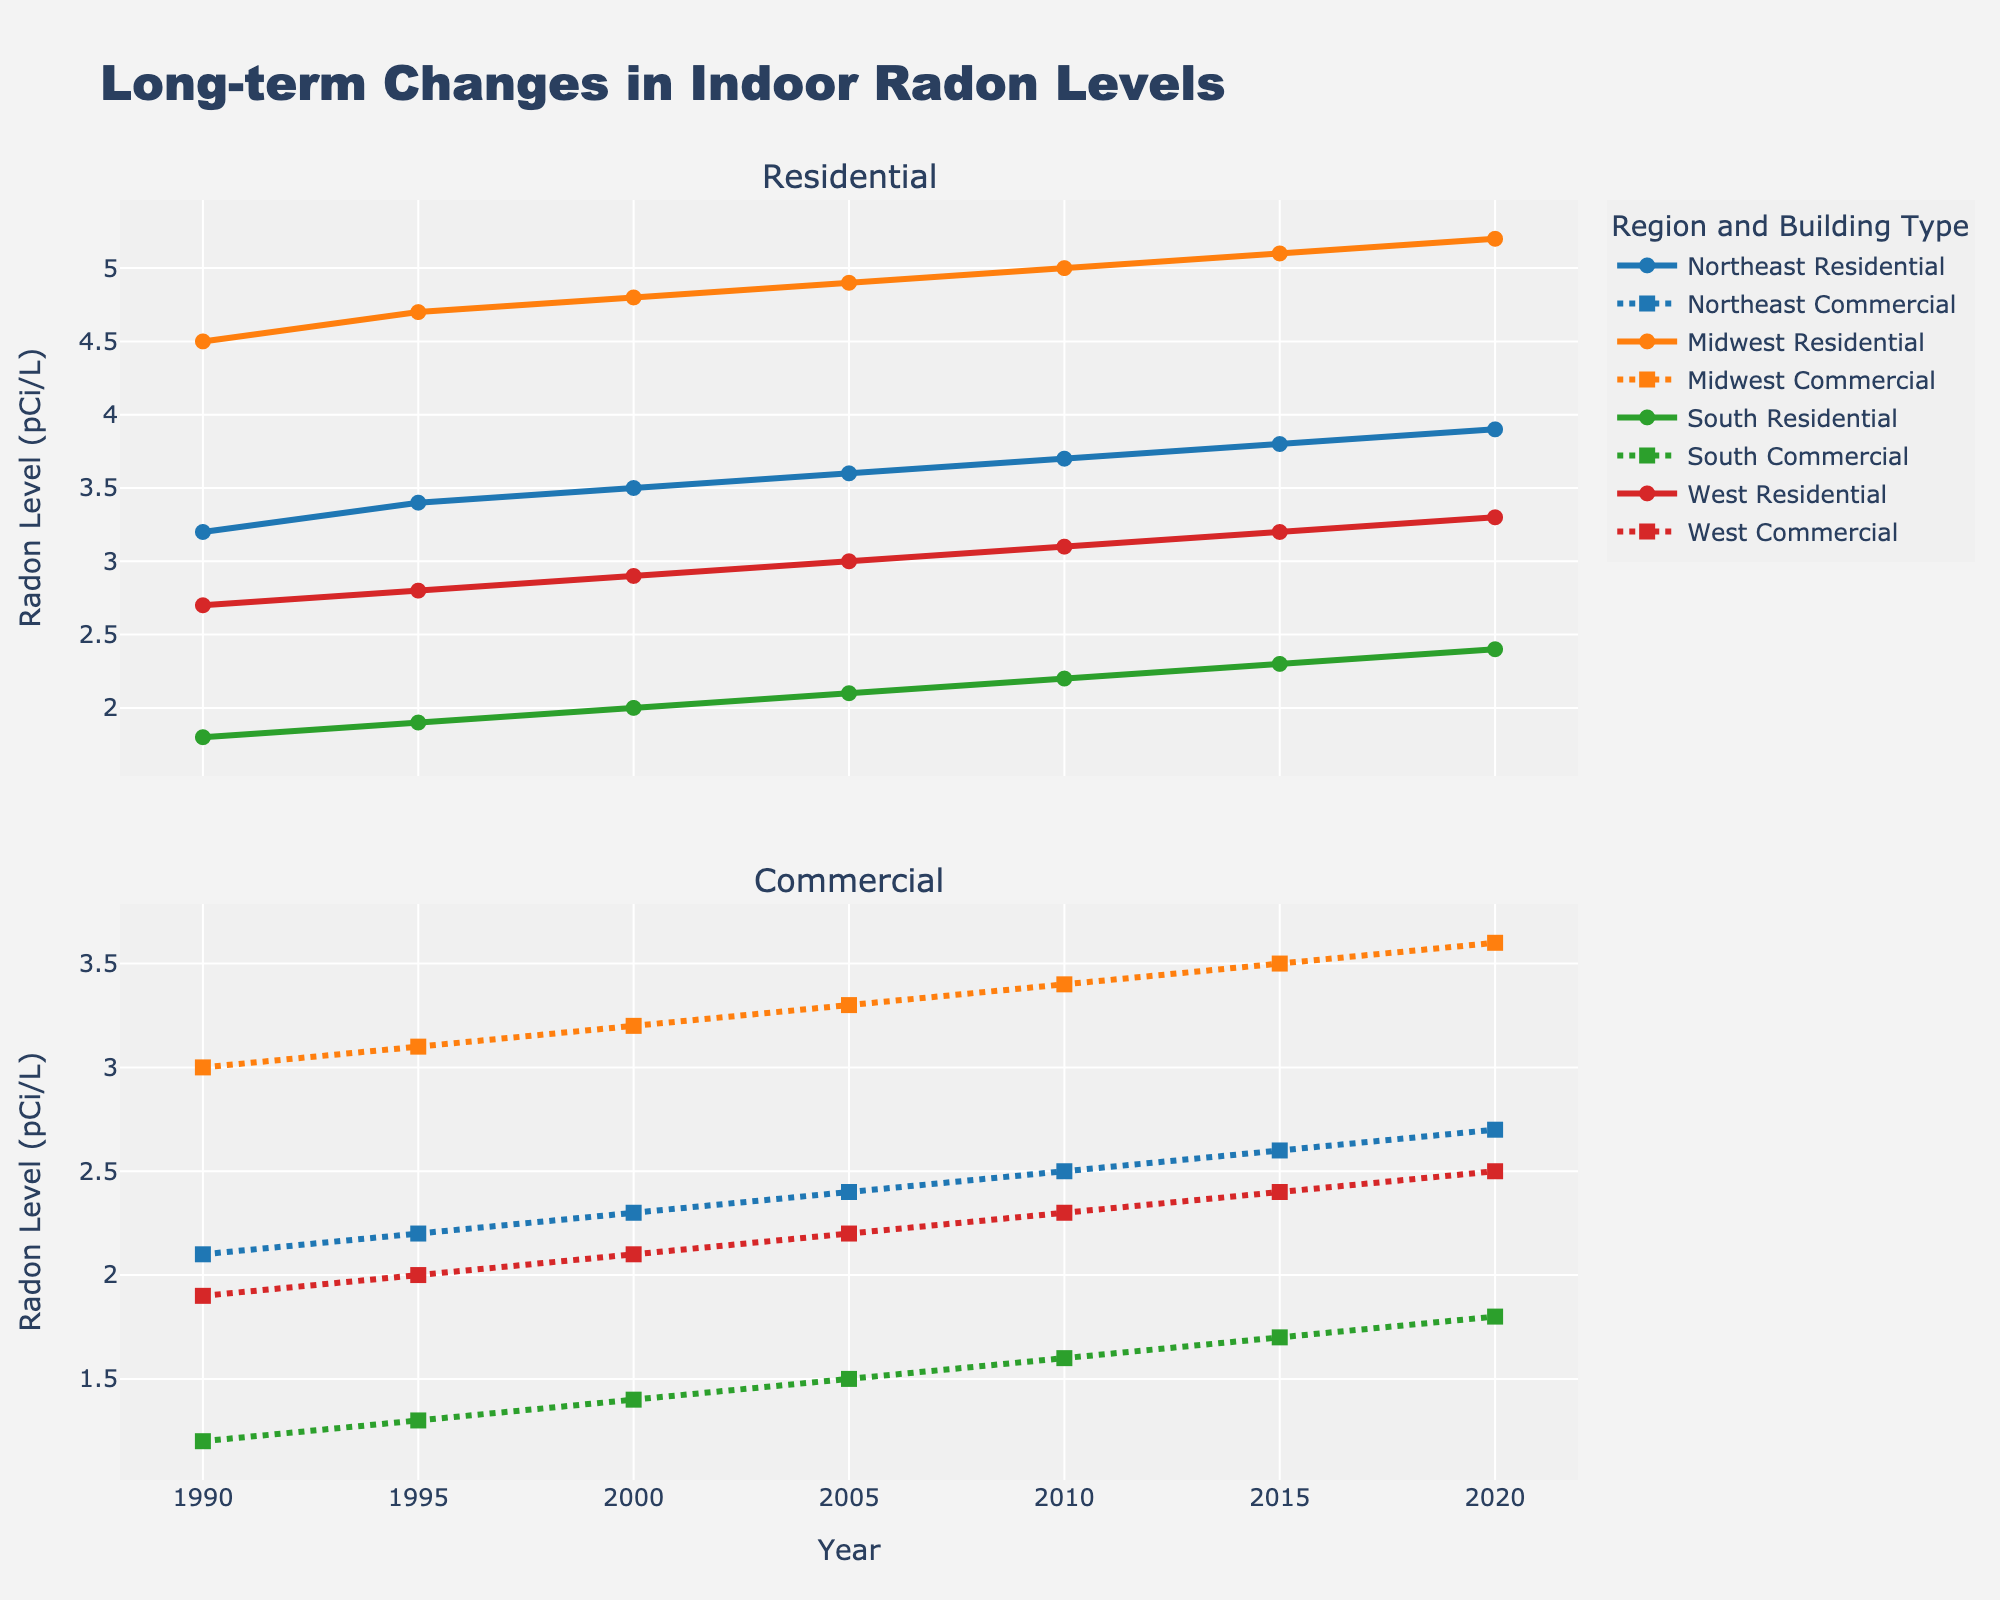Which region shows the highest residential radon level in 2020? Look at the line chart under the year 2020 in the upper subplot and check for the highest point. The Midwest Residential line reaches the highest value.
Answer: Midwest How did the radon levels in South Commercial buildings change from 1990 to 2020? Follow the South Commercial line in the lower subplot from 1990 to 2020. The values increased from 1.2 in 1990 to 1.8 in 2020.
Answer: Increased What is the general trend of radon levels in Northeast Residential buildings from 1990 to 2020? Observe the Northeast Residential line in the upper subplot. The line shows a steady upward trend from 1990 to 2020.
Answer: Upward trend Compare the radon levels in Midwest Commercial buildings to South Residential buildings in 2010. Which one is higher? Locate the year 2010 on the horizontal axis and compare the values of Midwest Commercial and South Residential lines. Midwest Commercial (3.4) is higher than South Residential (2.2).
Answer: Midwest Commercial What is the average radon level in West Residential buildings from 1990 to 2020? Sum the values for West Residential from each year and divide by the number of years ((2.7+2.8+2.9+3.0+3.1+3.2+3.3)/7).
Answer: 2.86 How much did the radon level in Midwest Residential buildings increase from 1995 to 2020? Calculate the difference between the Midwest Residential values in 2020 and 1995 (5.2 - 4.7).
Answer: 0.5 Which building type and region showed the least change in radon levels from 1990 to 2020? Assess all lines for the smallest difference between 1990 and 2020 values. South Commercial increased from 1.2 to 1.8, the smallest change.
Answer: South Commercial Compare the steepness of radon level increase between Northeast Residential and Midwest Residential buildings from 1990 to 2020. Which one is steeper? Look at the slopes of both lines between 1990 and 2020. The slope for Midwest Residential appears steeper as it went from 4.5 to 5.2 than Northeast Residential which went from 3.2 to 3.9.
Answer: Midwest Residential Among all regions' Commercial buildings, which had the highest radon level in 2020? Compare the values for all Commercial lines in the lower subplot for 2020. Midwest Commercial has the highest value at 3.6.
Answer: Midwest What is the overall change in radon levels for West Commercial buildings from 1990 to 2020? Calculate the difference between the West Commercial values in 2020 and 1990 (2.5 - 1.9).
Answer: 0.6 